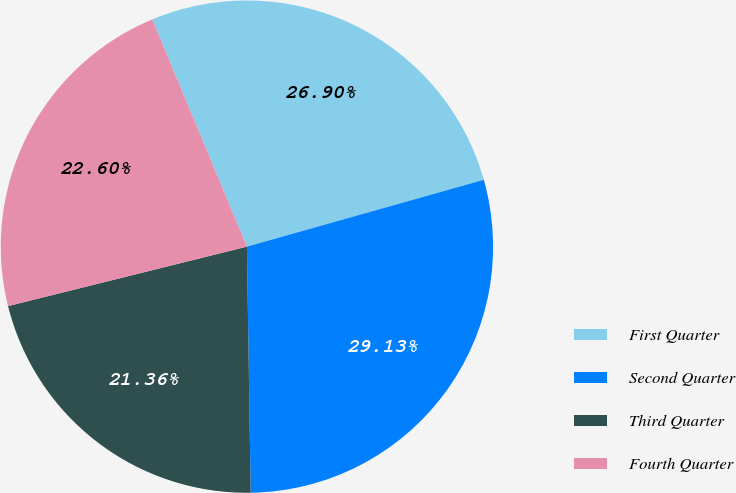Convert chart to OTSL. <chart><loc_0><loc_0><loc_500><loc_500><pie_chart><fcel>First Quarter<fcel>Second Quarter<fcel>Third Quarter<fcel>Fourth Quarter<nl><fcel>26.9%<fcel>29.13%<fcel>21.36%<fcel>22.6%<nl></chart> 